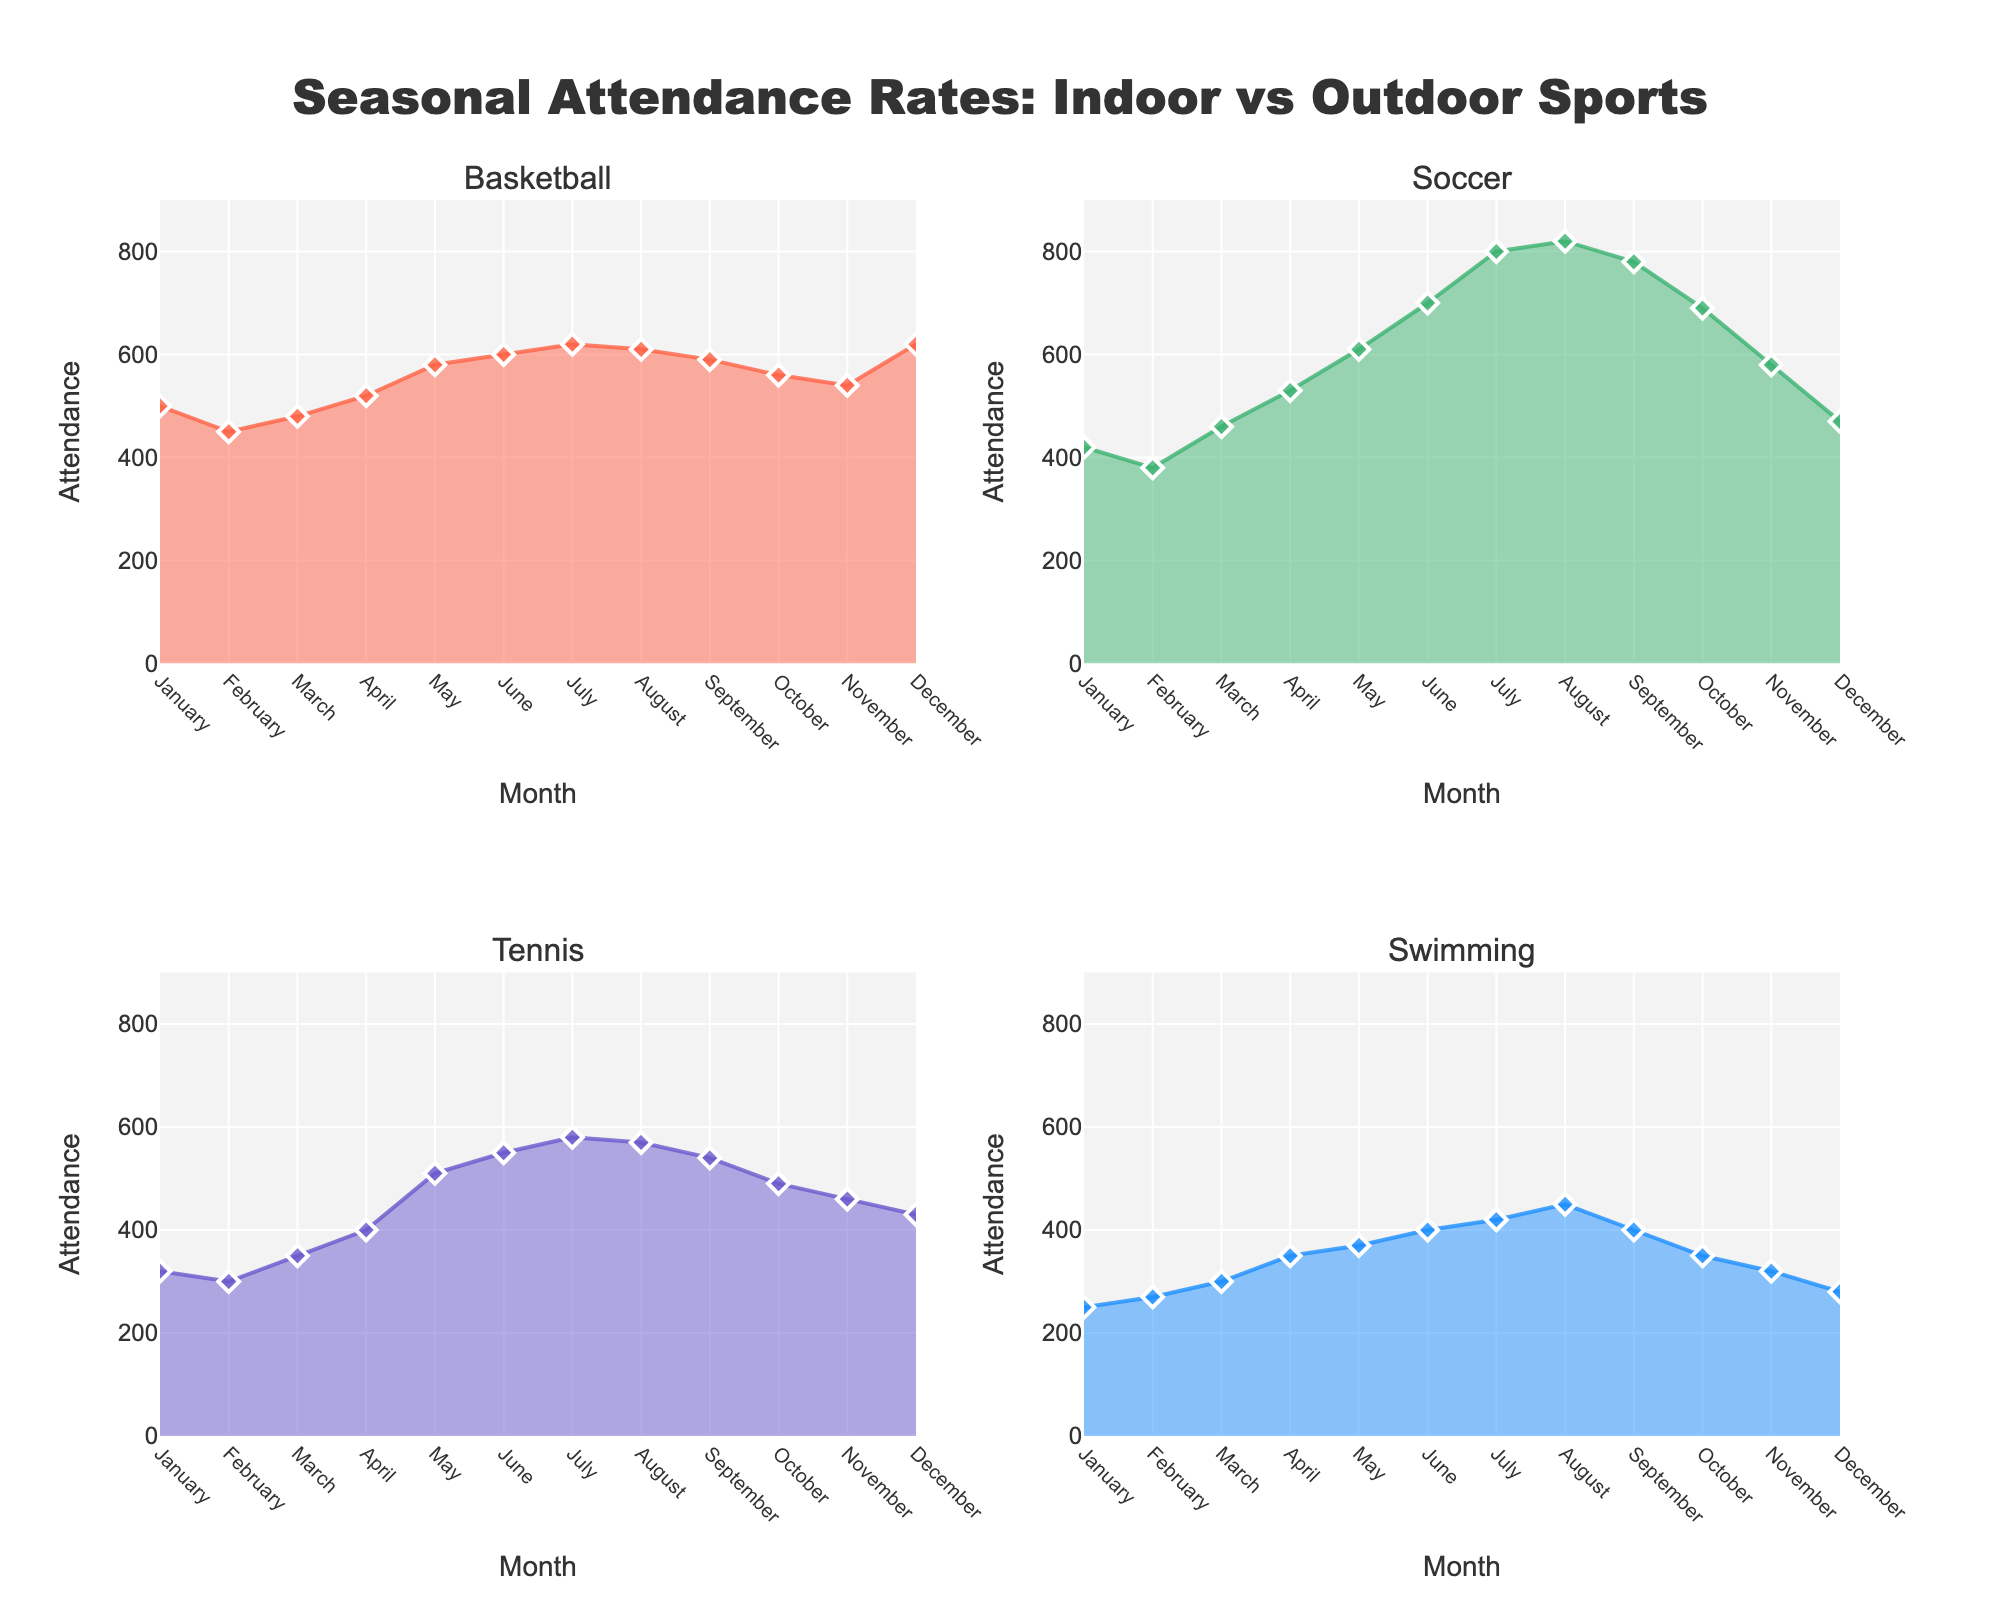What is the title of the figure? The title is located above the figure; it reads "Seasonal Attendance Rates: Indoor vs Outdoor Sports".
Answer: Seasonal Attendance Rates: Indoor vs Outdoor Sports Which month has the highest attendance for Basketball? By looking at the Basketball subplot, the highest attendance is in December, with an attendance of 620.
Answer: December Compare the peak attendance months for Soccer and Tennis. Which sport had a higher peak attendance and what was the attendance? For Soccer, the peak attendance is in August at 820. For Tennis, the peak attendance is in July at 580. Since 820 is greater than 580, Soccer had a higher peak attendance.
Answer: Soccer, 820 What is the average attendance for Swimming across all months? First, sum the attendance for all months: 250 + 270 + 300 + 350 + 370 + 400 + 420 + 450 + 400 + 350 + 320 + 280 = 4560. Then divide by 12 (the number of months). 4560 / 12 = 380.
Answer: 380 In which months did Tennis have higher attendance than Basketball? By comparing the Tennis and Basketball subplots month by month: Tennis attendance is higher in January, February, and March.
Answer: January, February, March What is the attendance range (difference between highest and lowest attendance) for Soccer? The highest attendance for Soccer is 820 (August) and the lowest is 380 (February). The range is 820 - 380 = 440.
Answer: 440 During which month does Swimming show a significant increase in attendance compared to the previous month? Comparing month-to-month in the Swimming subplot, March shows a significant increase going from 270 to 300, and then again from March to April (350 to 400). The most significant increase is from 300 to 350 in April.
Answer: April How does the attendance trend for Basketball compare to that of Swimming from June to August? Basketball shows a slight decrease from 600 (June) to 610 (August). Swimming shows an increase from 400 (June) to 450 (August). Basketball's trend is stabilization whereas Swimming's trend is an upward increase.
Answer: Basketball: slight decrease, Swimming: increase Which sport has the least variation in attendance throughout the year? By visually comparing the plots, Swimming shows the least variation as its attendance fluctuates within a smaller range compared to the other sports.
Answer: Swimming 